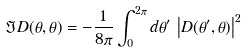Convert formula to latex. <formula><loc_0><loc_0><loc_500><loc_500>\Im D ( \theta , \theta ) = - \frac { 1 } { 8 \pi } \int _ { 0 } ^ { 2 \pi } d \theta ^ { \prime } \, \left | D ( \theta ^ { \prime } , \theta ) \right | ^ { 2 }</formula> 